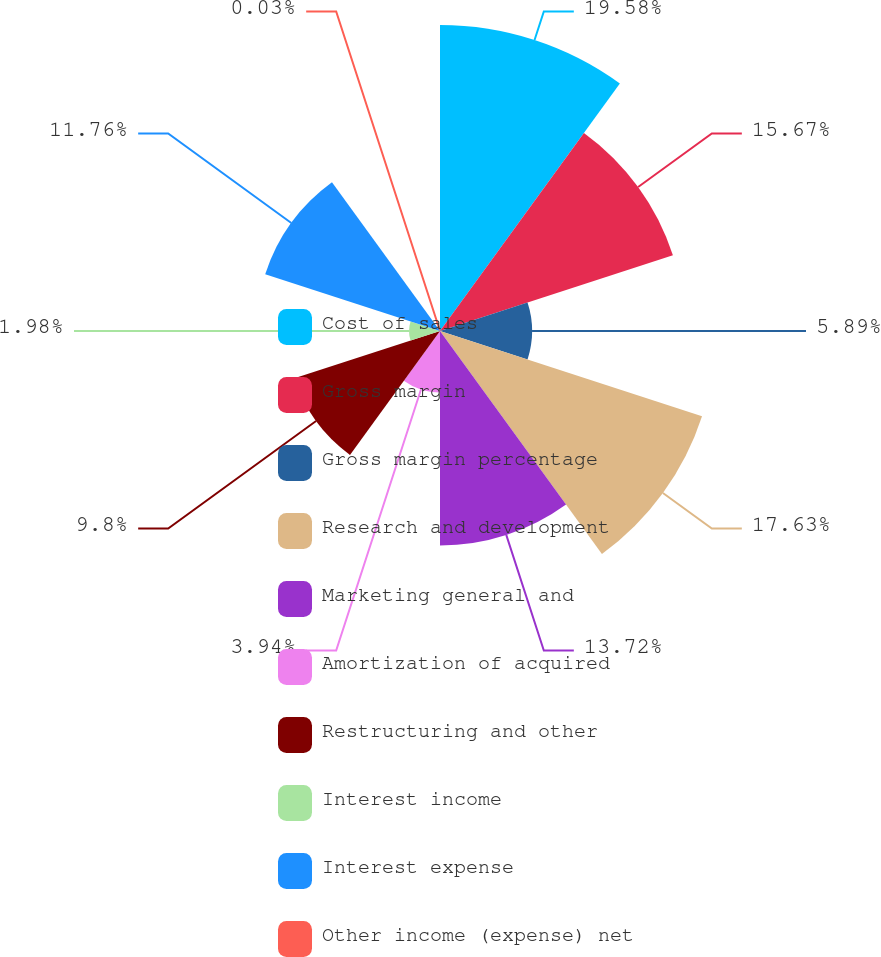Convert chart to OTSL. <chart><loc_0><loc_0><loc_500><loc_500><pie_chart><fcel>Cost of sales<fcel>Gross margin<fcel>Gross margin percentage<fcel>Research and development<fcel>Marketing general and<fcel>Amortization of acquired<fcel>Restructuring and other<fcel>Interest income<fcel>Interest expense<fcel>Other income (expense) net<nl><fcel>19.58%<fcel>15.67%<fcel>5.89%<fcel>17.63%<fcel>13.72%<fcel>3.94%<fcel>9.8%<fcel>1.98%<fcel>11.76%<fcel>0.03%<nl></chart> 